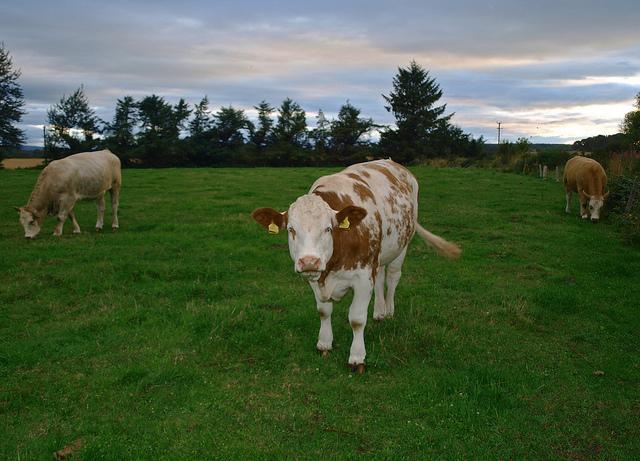Do any of the cows have horns?
Keep it brief. No. What time of day is it?
Keep it brief. Evening. Overcast or sunny?
Give a very brief answer. Overcast. Is that a mother elk?
Give a very brief answer. No. What are the animals eating?
Quick response, please. Grass. Are these cows going to be eaten?
Give a very brief answer. Yes. What are the animals standing on?
Quick response, please. Grass. 